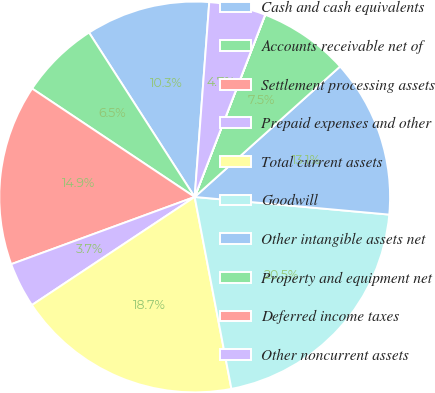Convert chart to OTSL. <chart><loc_0><loc_0><loc_500><loc_500><pie_chart><fcel>Cash and cash equivalents<fcel>Accounts receivable net of<fcel>Settlement processing assets<fcel>Prepaid expenses and other<fcel>Total current assets<fcel>Goodwill<fcel>Other intangible assets net<fcel>Property and equipment net<fcel>Deferred income taxes<fcel>Other noncurrent assets<nl><fcel>10.28%<fcel>6.55%<fcel>14.95%<fcel>3.74%<fcel>18.68%<fcel>20.55%<fcel>13.08%<fcel>7.48%<fcel>0.01%<fcel>4.68%<nl></chart> 